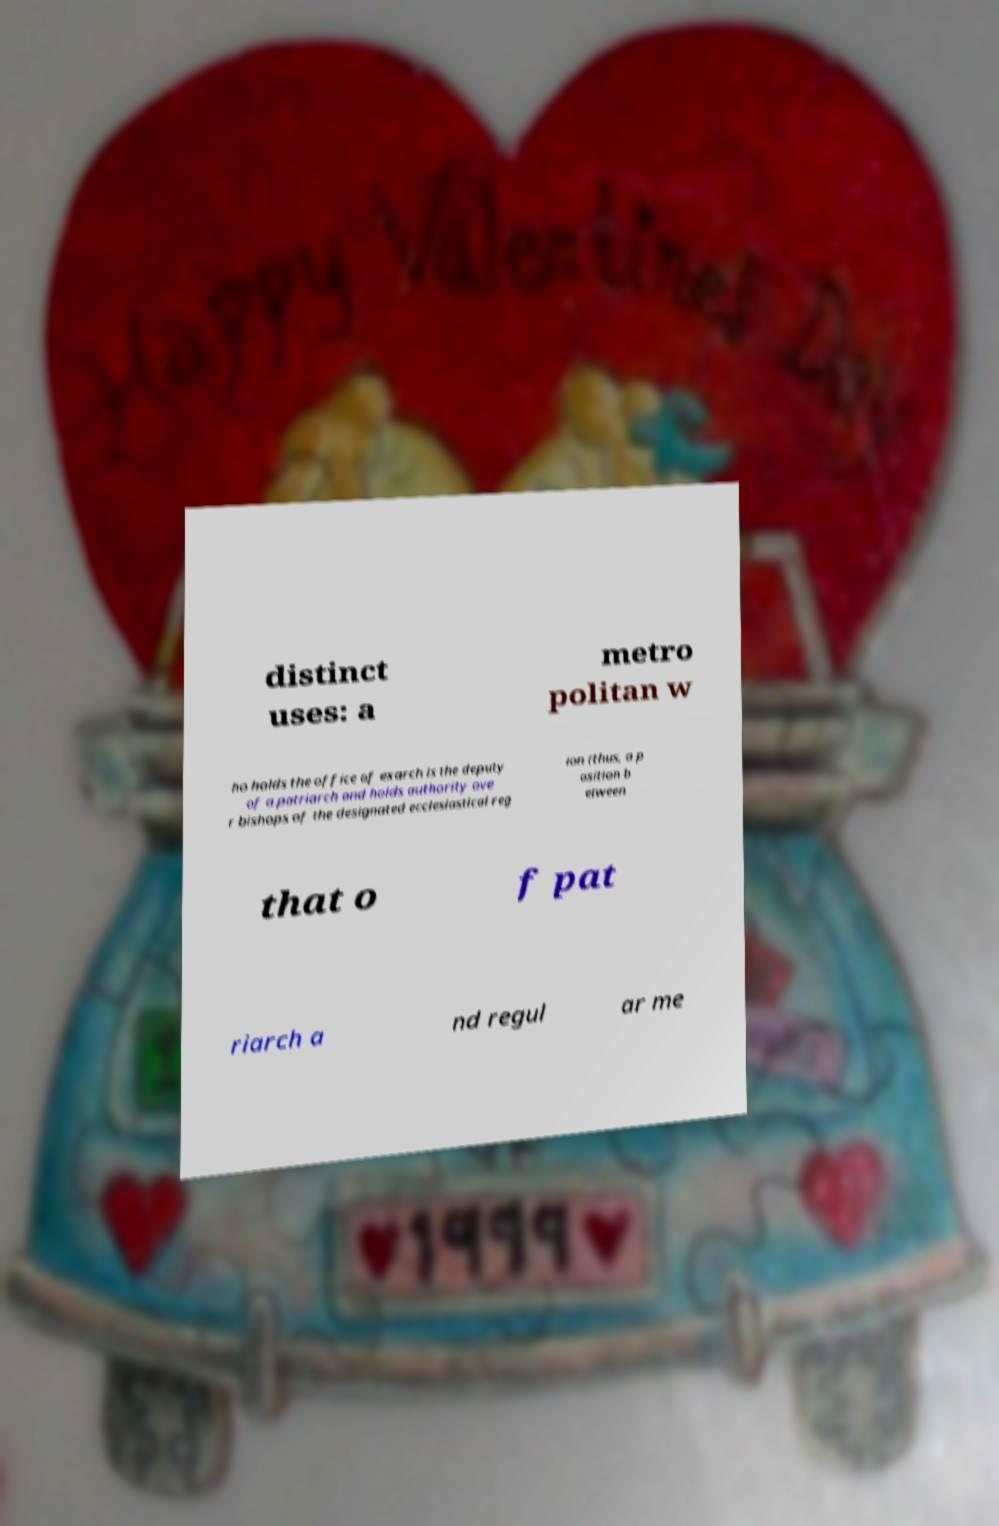Could you extract and type out the text from this image? distinct uses: a metro politan w ho holds the office of exarch is the deputy of a patriarch and holds authority ove r bishops of the designated ecclesiastical reg ion (thus, a p osition b etween that o f pat riarch a nd regul ar me 